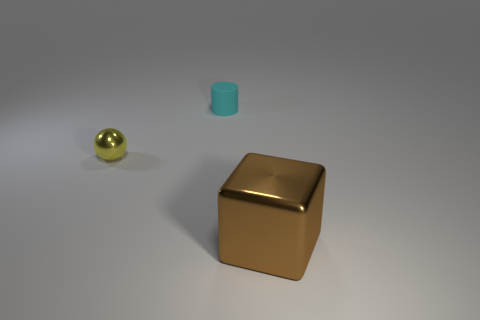Add 2 shiny things. How many objects exist? 5 Subtract all cubes. How many objects are left? 2 Subtract all small yellow balls. Subtract all tiny yellow metal balls. How many objects are left? 1 Add 2 cyan matte things. How many cyan matte things are left? 3 Add 3 yellow cylinders. How many yellow cylinders exist? 3 Subtract 1 yellow spheres. How many objects are left? 2 